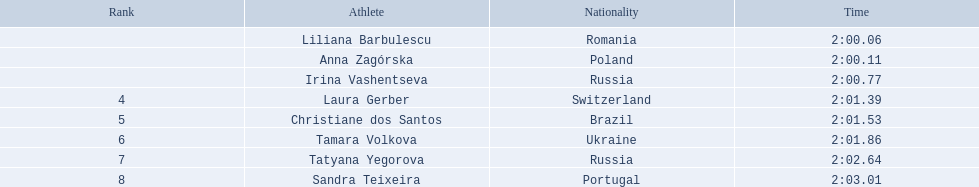Who were all the sportspeople? Liliana Barbulescu, Anna Zagórska, Irina Vashentseva, Laura Gerber, Christiane dos Santos, Tamara Volkova, Tatyana Yegorova, Sandra Teixeira. What were their completion times? 2:00.06, 2:00.11, 2:00.77, 2:01.39, 2:01.53, 2:01.86, 2:02.64, 2:03.01. Which sportsman finished first? Liliana Barbulescu. 